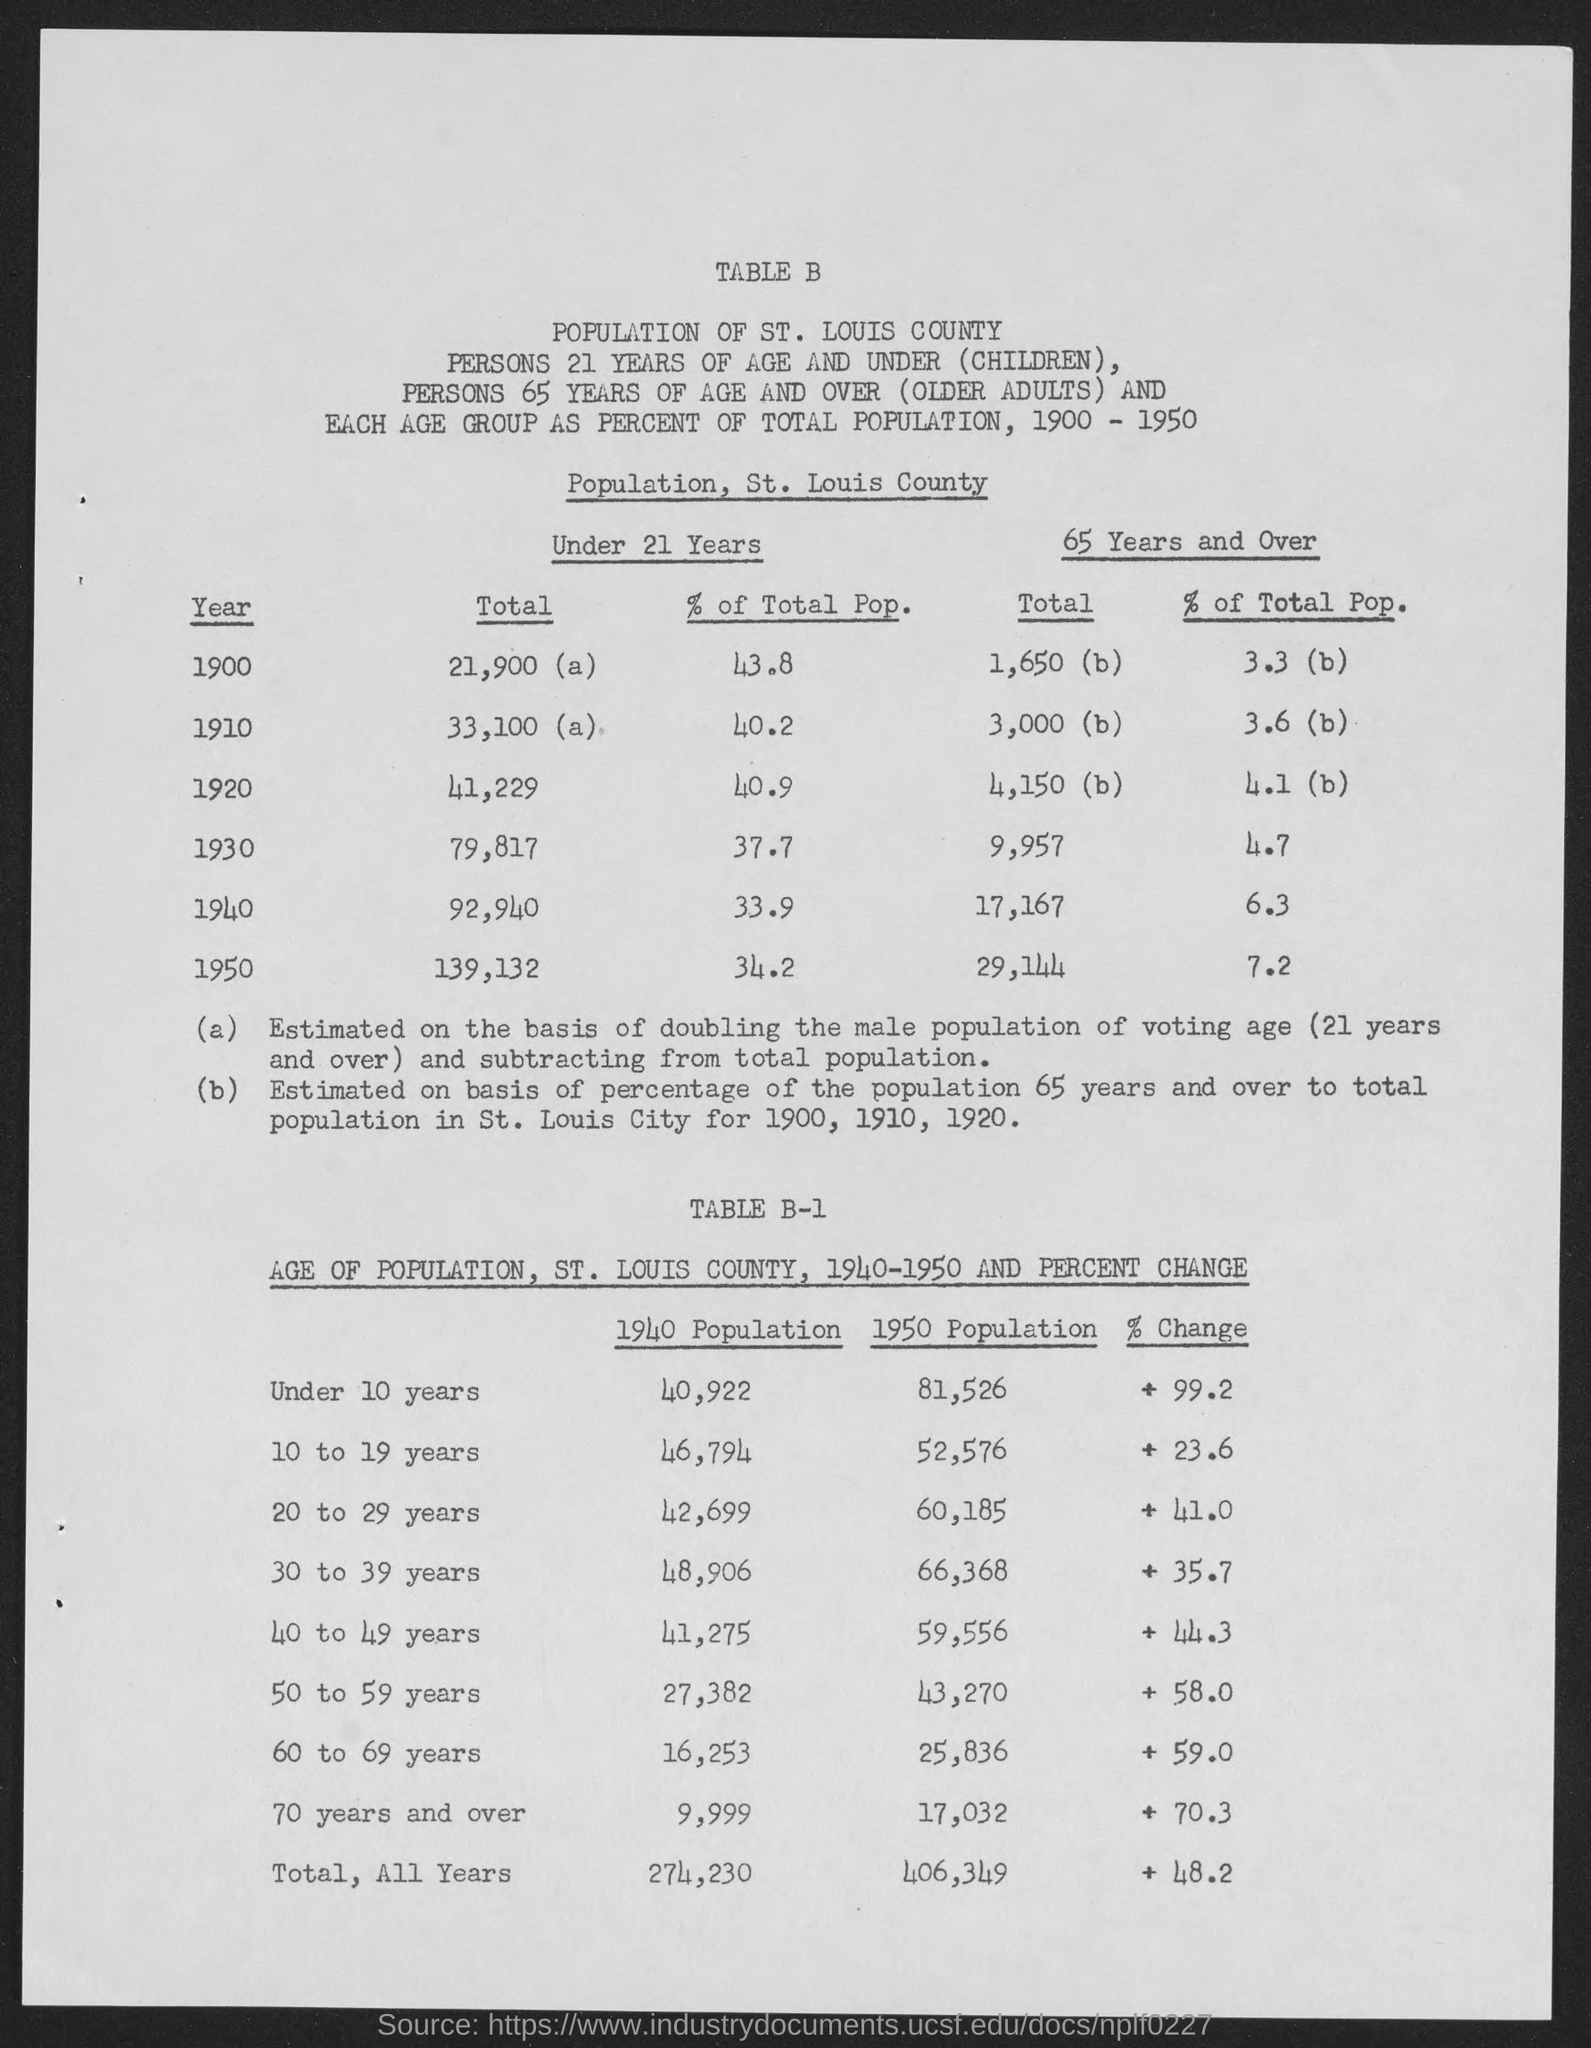What is the total population under 21 years in 1900?
Provide a short and direct response. 21,900. What is the total population under 21 years  in 1920?
Give a very brief answer. 41,229. What is the total population under 21 years  in 1930?
Provide a succinct answer. 79,817. What is the total population under 21 years  in 1940?
Give a very brief answer. 92,940. What is the total population under 21 years in 1950?
Ensure brevity in your answer.  139,132. 